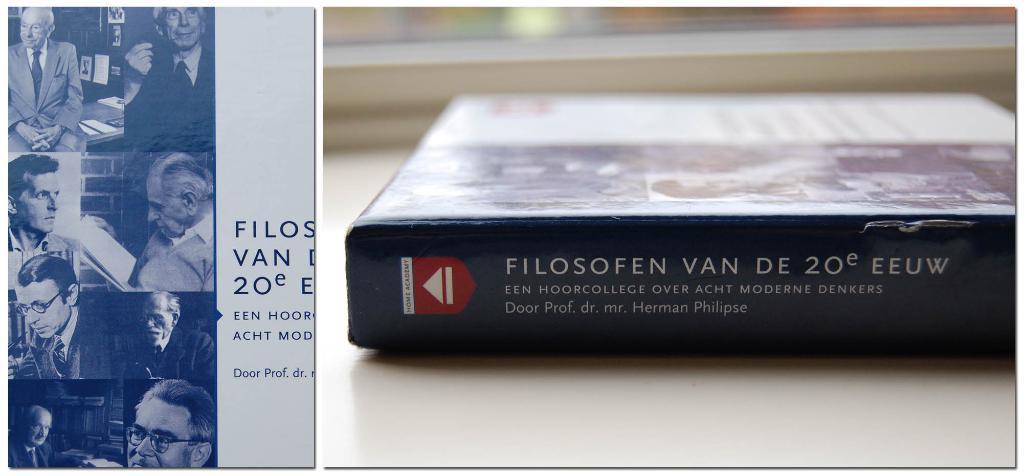What is the name of the professor on the spine of the book?
Offer a very short reply. Herman philipse. 